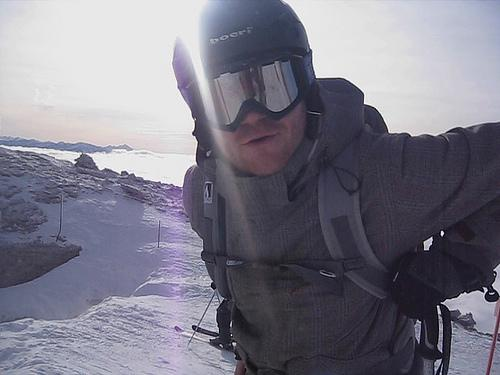What nationality were the founders of this helmet company? italian 